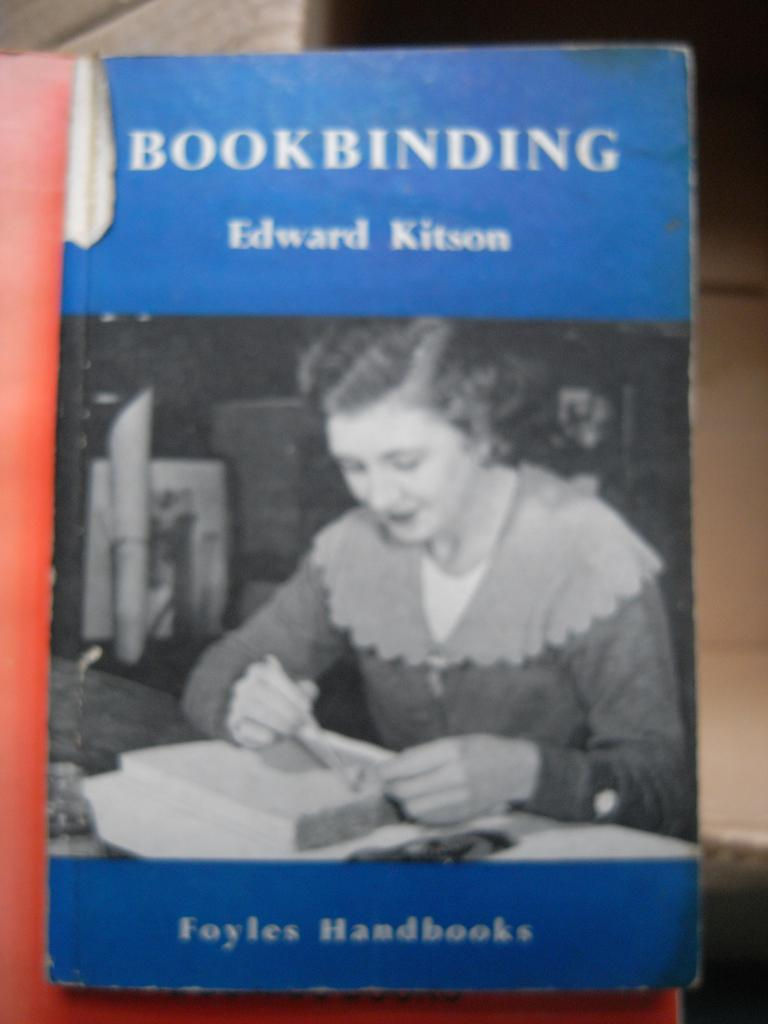<image>
Present a compact description of the photo's key features. A book that is entitled Bookbinding by Edward Kitson. 